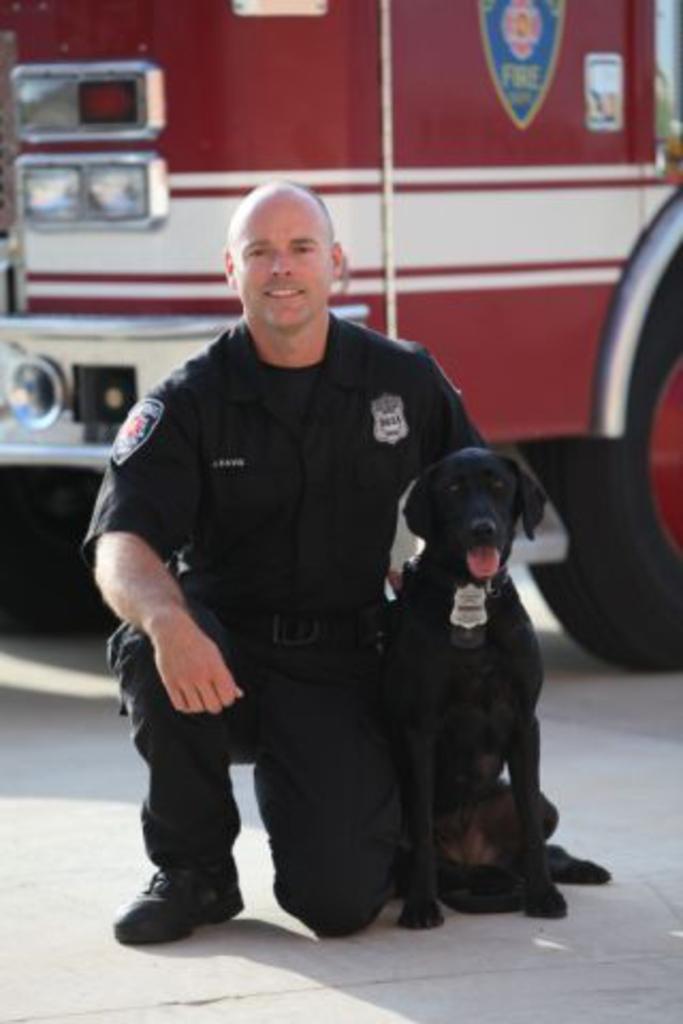Could you give a brief overview of what you see in this image? This picture is clicked outside the city. Man in black shirt is smiling. Beside him, we see a black dog sitting next to him. Behind the man, we see a vehicle which is in red and white color. 